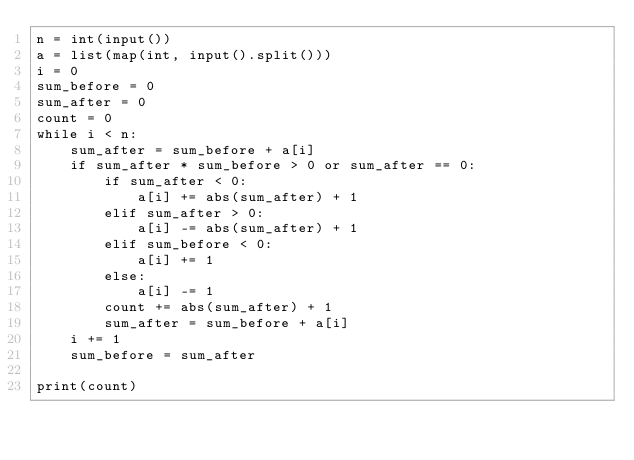<code> <loc_0><loc_0><loc_500><loc_500><_Python_>n = int(input())
a = list(map(int, input().split()))
i = 0
sum_before = 0
sum_after = 0
count = 0
while i < n:
    sum_after = sum_before + a[i]
    if sum_after * sum_before > 0 or sum_after == 0:
        if sum_after < 0:
            a[i] += abs(sum_after) + 1
        elif sum_after > 0:
            a[i] -= abs(sum_after) + 1
        elif sum_before < 0:
            a[i] += 1
        else:
            a[i] -= 1
        count += abs(sum_after) + 1
        sum_after = sum_before + a[i]
    i += 1
    sum_before = sum_after

print(count)
 


</code> 